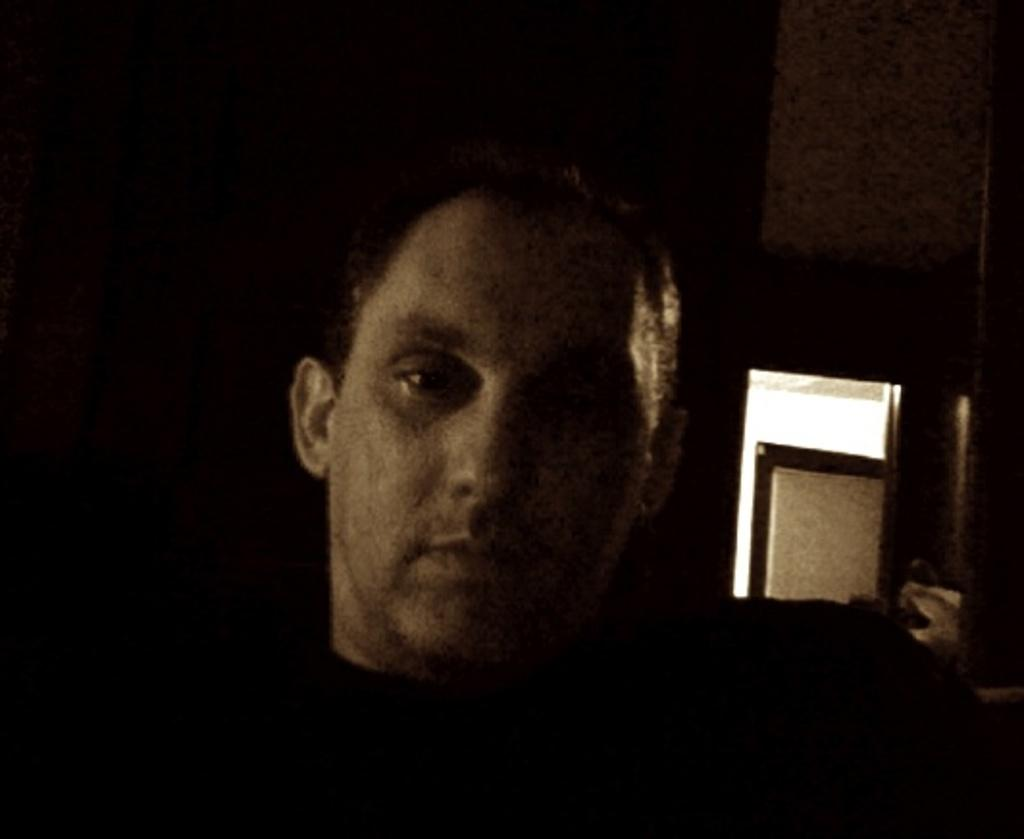What is the main subject in the foreground of the image? There is a person in the foreground of the image. What can be seen in the background of the image? There is a wall and a door in the background of the image. Can you tell me how many horses are standing next to the person in the image? There are no horses present in the image; it only features a person, a wall, and a door. 